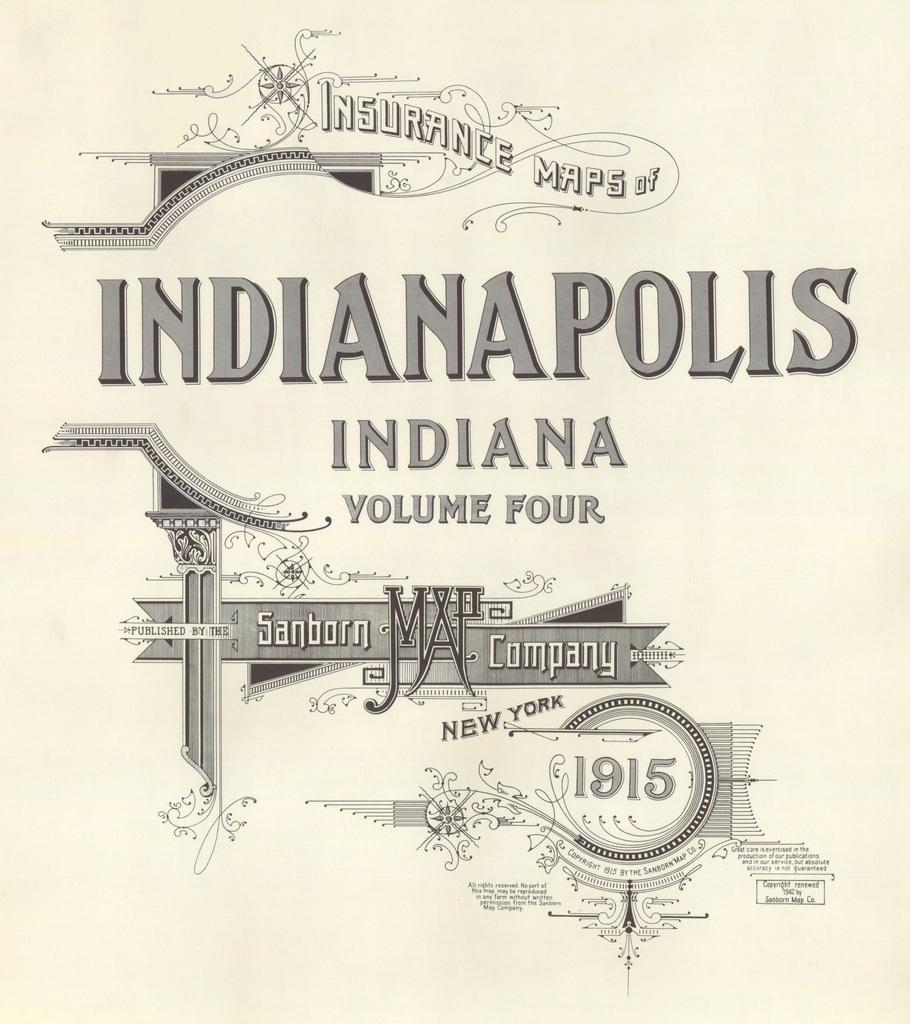Provide a one-sentence caption for the provided image. An old insurance map of Indianapolis, Indiana dated 1915 by the Sanborn Map Company in New York. 